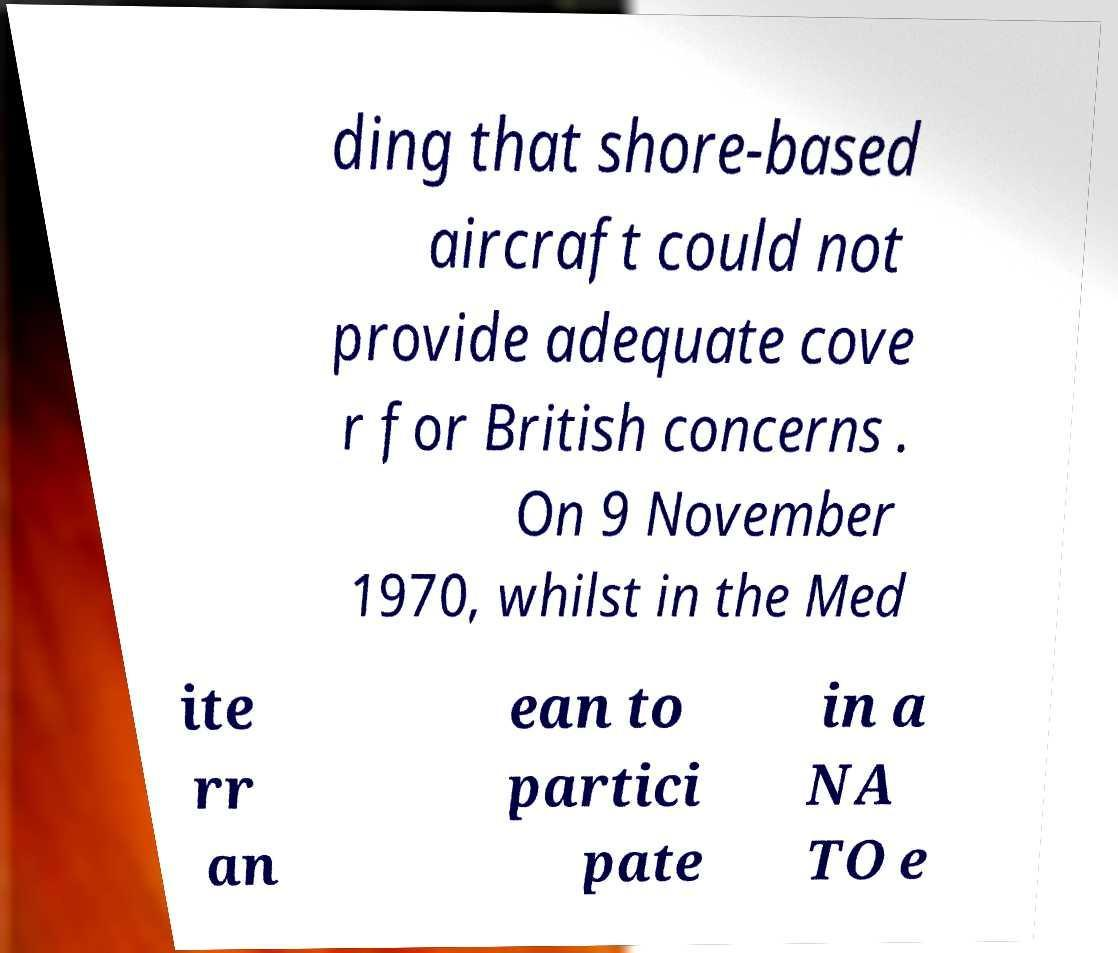There's text embedded in this image that I need extracted. Can you transcribe it verbatim? ding that shore-based aircraft could not provide adequate cove r for British concerns . On 9 November 1970, whilst in the Med ite rr an ean to partici pate in a NA TO e 